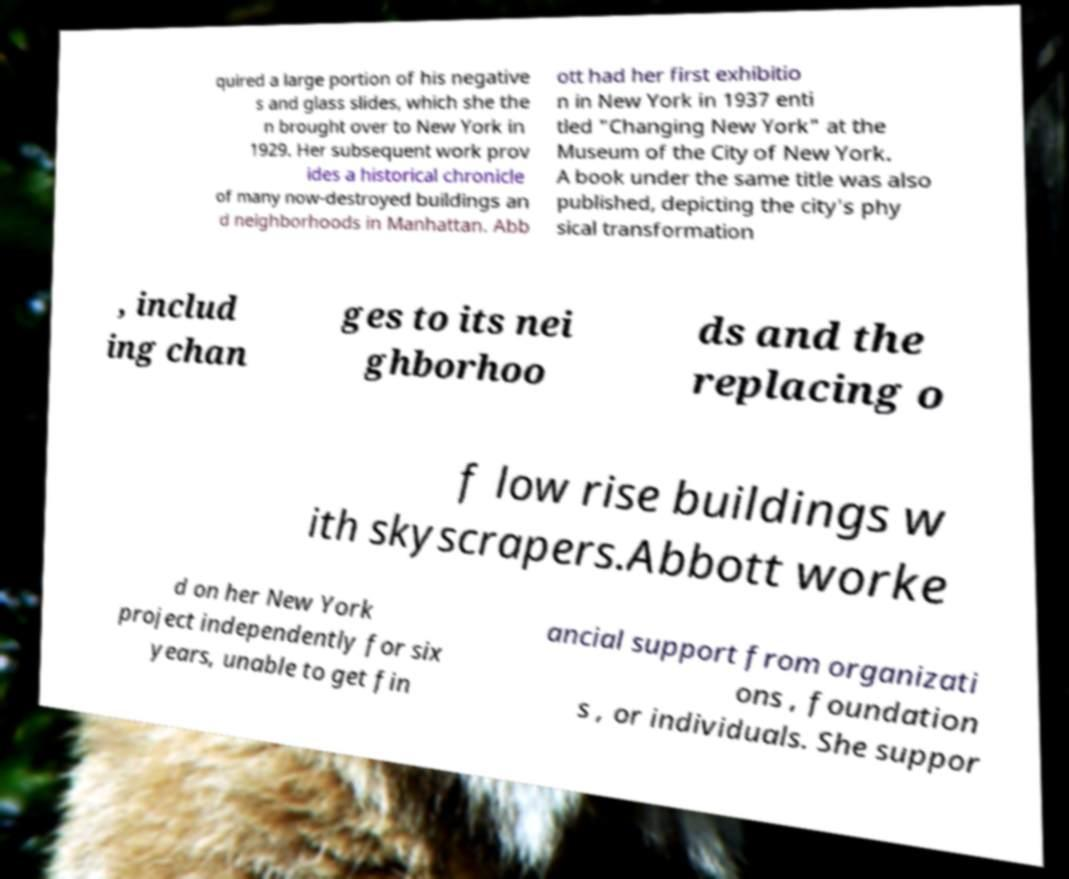There's text embedded in this image that I need extracted. Can you transcribe it verbatim? quired a large portion of his negative s and glass slides, which she the n brought over to New York in 1929. Her subsequent work prov ides a historical chronicle of many now-destroyed buildings an d neighborhoods in Manhattan. Abb ott had her first exhibitio n in New York in 1937 enti tled "Changing New York" at the Museum of the City of New York. A book under the same title was also published, depicting the city's phy sical transformation , includ ing chan ges to its nei ghborhoo ds and the replacing o f low rise buildings w ith skyscrapers.Abbott worke d on her New York project independently for six years, unable to get fin ancial support from organizati ons , foundation s , or individuals. She suppor 